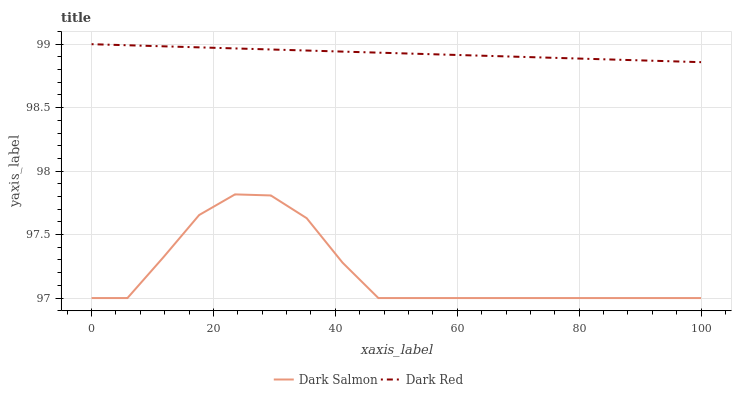Does Dark Salmon have the minimum area under the curve?
Answer yes or no. Yes. Does Dark Red have the maximum area under the curve?
Answer yes or no. Yes. Does Dark Salmon have the maximum area under the curve?
Answer yes or no. No. Is Dark Red the smoothest?
Answer yes or no. Yes. Is Dark Salmon the roughest?
Answer yes or no. Yes. Is Dark Salmon the smoothest?
Answer yes or no. No. Does Dark Salmon have the lowest value?
Answer yes or no. Yes. Does Dark Red have the highest value?
Answer yes or no. Yes. Does Dark Salmon have the highest value?
Answer yes or no. No. Is Dark Salmon less than Dark Red?
Answer yes or no. Yes. Is Dark Red greater than Dark Salmon?
Answer yes or no. Yes. Does Dark Salmon intersect Dark Red?
Answer yes or no. No. 